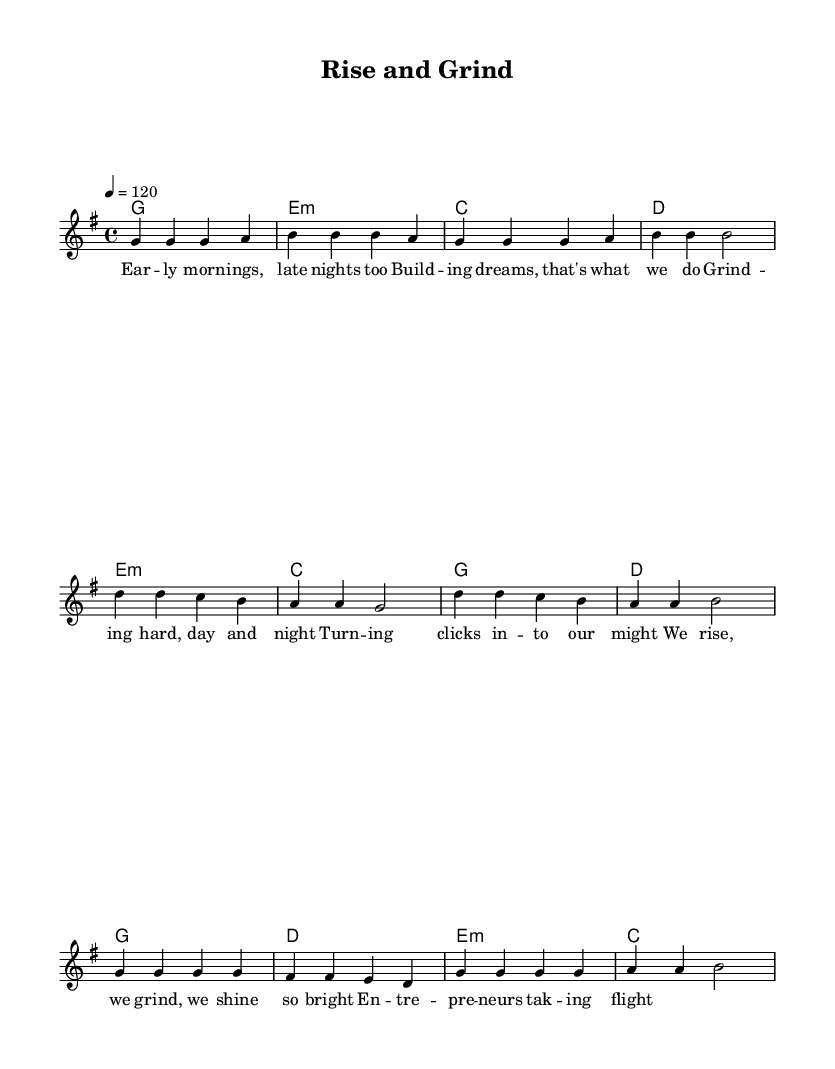What is the key signature of this music? The key signature is G major, which has one sharp (F#). This can be determined by looking at the beginning of the sheet music, where the key signature is indicated.
Answer: G major What is the time signature of this piece? The time signature is 4/4, which indicates that there are four beats in each measure and the quarter note gets one beat. This is found at the start of the music following the key signature.
Answer: 4/4 What is the tempo marking? The tempo marking is 120 beats per minute, which is indicated at the beginning of the music. This tells the musician how fast to play the piece.
Answer: 120 How many measures are in the chorus section? The chorus section consists of four measures. This can be counted directly from the notation in the chorus section of the sheet music.
Answer: Four In what section does the lyric "Grind-ing hard, day and night" appear? This lyric appears in the prechorus section. By looking at the lyrics assigned to each musical section, we can confirm the location of the specified line.
Answer: Prechorus What type of harmony appears in the first measure of the music? The first measure’s harmony is G major. By checking the chord progression notated at the beginning of the score, this can be confirmed.
Answer: G major What lyrical theme is celebrated in this anthem? The main theme celebrated in this anthem is entrepreneurship. This is derived from the context of the lyrics which focus on rising, grinding, and achieving financial independence as an entrepreneur.
Answer: Entrepreneurship 